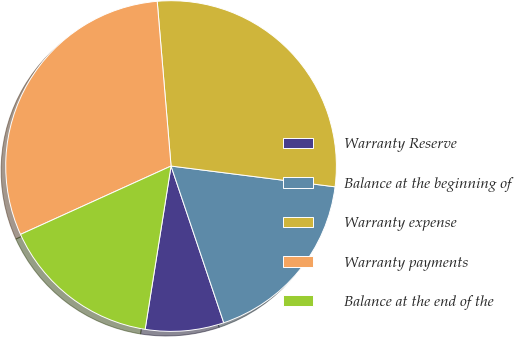Convert chart. <chart><loc_0><loc_0><loc_500><loc_500><pie_chart><fcel>Warranty Reserve<fcel>Balance at the beginning of<fcel>Warranty expense<fcel>Warranty payments<fcel>Balance at the end of the<nl><fcel>7.67%<fcel>17.83%<fcel>28.34%<fcel>30.45%<fcel>15.71%<nl></chart> 